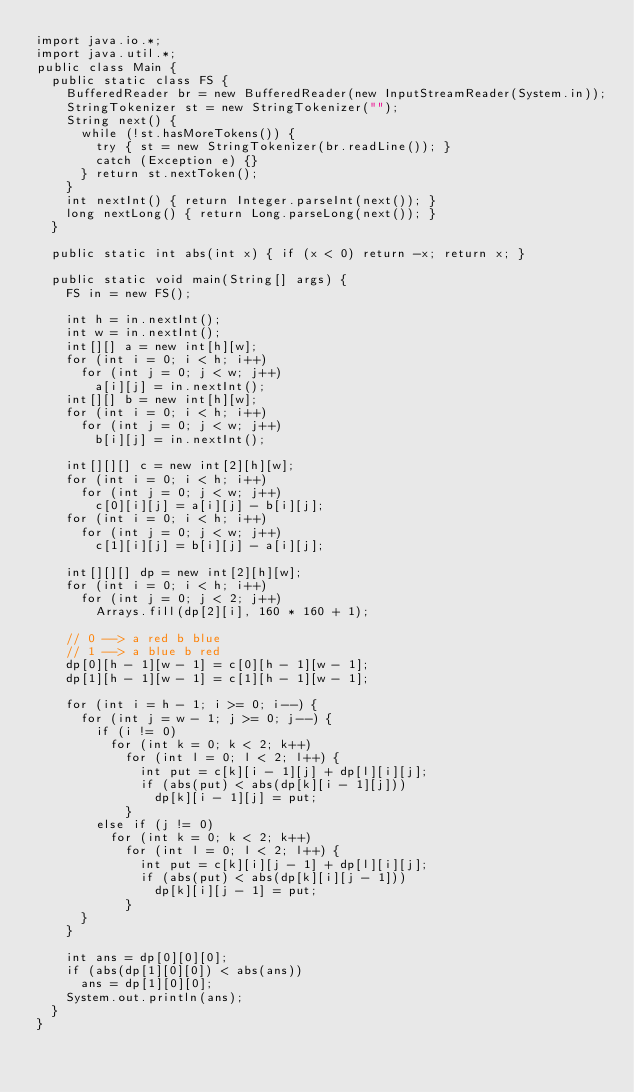Convert code to text. <code><loc_0><loc_0><loc_500><loc_500><_Java_>import java.io.*;
import java.util.*;
public class Main {
	public static class FS {
		BufferedReader br = new BufferedReader(new InputStreamReader(System.in));
		StringTokenizer st = new StringTokenizer("");
		String next() {
			while (!st.hasMoreTokens()) {
				try { st = new StringTokenizer(br.readLine()); }
				catch (Exception e) {}
			} return st.nextToken();
		}
		int nextInt() { return Integer.parseInt(next()); }
		long nextLong() { return Long.parseLong(next()); }
	}

	public static int abs(int x) { if (x < 0) return -x; return x; }

	public static void main(String[] args) {
		FS in = new FS();
	
		int h = in.nextInt();
		int w = in.nextInt();
		int[][] a = new int[h][w];
		for (int i = 0; i < h; i++)
			for (int j = 0; j < w; j++)
				a[i][j] = in.nextInt();
		int[][] b = new int[h][w];
		for (int i = 0; i < h; i++)
			for (int j = 0; j < w; j++)
				b[i][j] = in.nextInt();

		int[][][] c = new int[2][h][w];
		for (int i = 0; i < h; i++)
			for (int j = 0; j < w; j++)
				c[0][i][j] = a[i][j] - b[i][j];
		for (int i = 0; i < h; i++)
			for (int j = 0; j < w; j++)
				c[1][i][j] = b[i][j] - a[i][j];

		int[][][] dp = new int[2][h][w];
		for (int i = 0; i < h; i++)
			for (int j = 0; j < 2; j++)
				Arrays.fill(dp[2][i], 160 * 160 + 1);
		
		// 0 --> a red b blue
		// 1 --> a blue b red
		dp[0][h - 1][w - 1] = c[0][h - 1][w - 1];
		dp[1][h - 1][w - 1] = c[1][h - 1][w - 1];

		for (int i = h - 1; i >= 0; i--) {
			for (int j = w - 1; j >= 0; j--) {
				if (i != 0) 
					for (int k = 0; k < 2; k++)
						for (int l = 0; l < 2; l++) {
							int put = c[k][i - 1][j] + dp[l][i][j];
							if (abs(put) < abs(dp[k][i - 1][j]))
								dp[k][i - 1][j] = put;
						}
				else if (j != 0)
					for (int k = 0; k < 2; k++)
						for (int l = 0; l < 2; l++) {
							int put = c[k][i][j - 1] + dp[l][i][j];
							if (abs(put) < abs(dp[k][i][j - 1]))
								dp[k][i][j - 1] = put;
						}
			}
		}
		
		int ans = dp[0][0][0];
		if (abs(dp[1][0][0]) < abs(ans))
			ans = dp[1][0][0];
		System.out.println(ans);
	}
}
</code> 